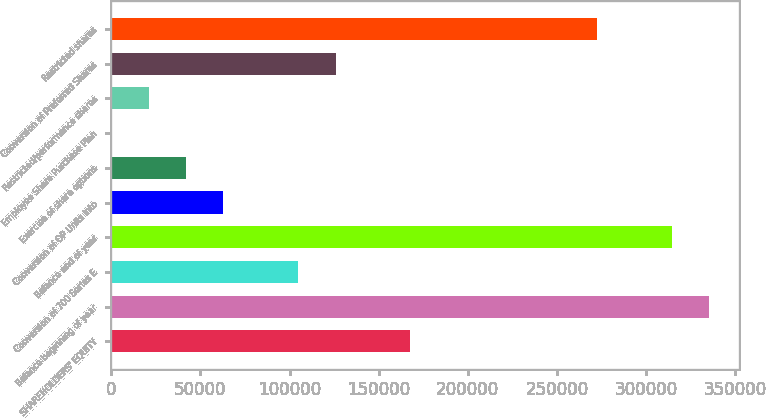Convert chart to OTSL. <chart><loc_0><loc_0><loc_500><loc_500><bar_chart><fcel>SHAREHOLDERS' EQUITY<fcel>Balance beginning of year<fcel>Conversion of 700 Series E<fcel>Balance end of year<fcel>Conversion of OP Units into<fcel>Exercise of share options<fcel>Employee Share Purchase Plan<fcel>Restricted/performance shares<fcel>Conversion of Preferred Shares<fcel>Restricted shares<nl><fcel>167730<fcel>335458<fcel>104832<fcel>314492<fcel>62900<fcel>41934<fcel>2<fcel>20968<fcel>125798<fcel>272560<nl></chart> 